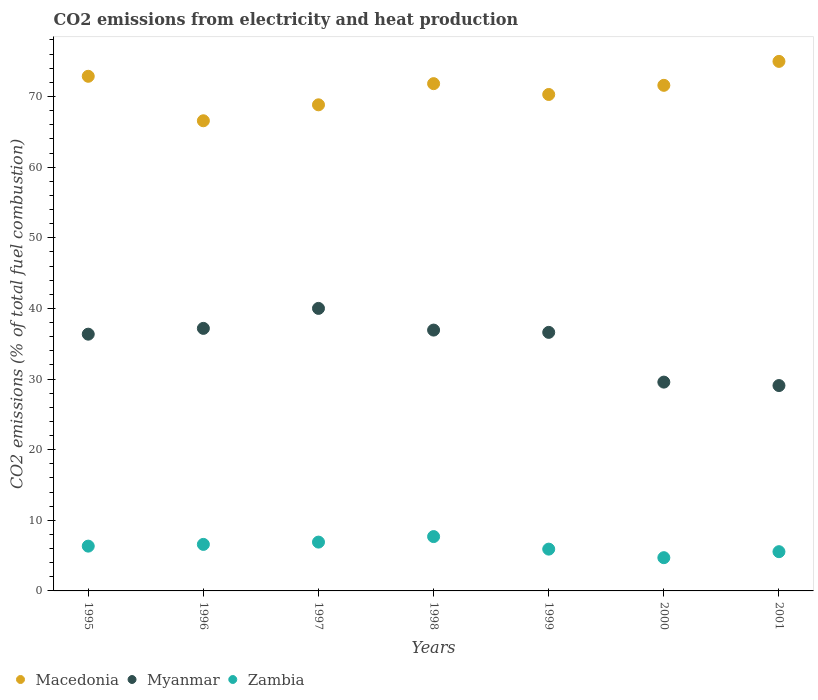How many different coloured dotlines are there?
Your response must be concise. 3. What is the amount of CO2 emitted in Myanmar in 1999?
Provide a succinct answer. 36.61. Across all years, what is the maximum amount of CO2 emitted in Myanmar?
Provide a succinct answer. 40. Across all years, what is the minimum amount of CO2 emitted in Myanmar?
Offer a very short reply. 29.08. What is the total amount of CO2 emitted in Zambia in the graph?
Offer a terse response. 43.71. What is the difference between the amount of CO2 emitted in Macedonia in 1997 and that in 2000?
Provide a succinct answer. -2.76. What is the difference between the amount of CO2 emitted in Zambia in 1999 and the amount of CO2 emitted in Macedonia in 2001?
Offer a terse response. -69.05. What is the average amount of CO2 emitted in Myanmar per year?
Provide a short and direct response. 35.1. In the year 1997, what is the difference between the amount of CO2 emitted in Macedonia and amount of CO2 emitted in Myanmar?
Your answer should be compact. 28.82. What is the ratio of the amount of CO2 emitted in Myanmar in 1996 to that in 2001?
Ensure brevity in your answer.  1.28. Is the amount of CO2 emitted in Zambia in 1997 less than that in 1998?
Provide a succinct answer. Yes. What is the difference between the highest and the second highest amount of CO2 emitted in Macedonia?
Provide a short and direct response. 2.11. What is the difference between the highest and the lowest amount of CO2 emitted in Zambia?
Your answer should be compact. 2.99. In how many years, is the amount of CO2 emitted in Macedonia greater than the average amount of CO2 emitted in Macedonia taken over all years?
Offer a very short reply. 4. Is it the case that in every year, the sum of the amount of CO2 emitted in Zambia and amount of CO2 emitted in Macedonia  is greater than the amount of CO2 emitted in Myanmar?
Your answer should be compact. Yes. Does the amount of CO2 emitted in Zambia monotonically increase over the years?
Provide a succinct answer. No. How many dotlines are there?
Provide a succinct answer. 3. How many years are there in the graph?
Provide a succinct answer. 7. Are the values on the major ticks of Y-axis written in scientific E-notation?
Provide a succinct answer. No. Does the graph contain any zero values?
Give a very brief answer. No. Where does the legend appear in the graph?
Your response must be concise. Bottom left. How many legend labels are there?
Provide a short and direct response. 3. What is the title of the graph?
Your answer should be very brief. CO2 emissions from electricity and heat production. Does "Zimbabwe" appear as one of the legend labels in the graph?
Give a very brief answer. No. What is the label or title of the X-axis?
Your answer should be compact. Years. What is the label or title of the Y-axis?
Offer a terse response. CO2 emissions (% of total fuel combustion). What is the CO2 emissions (% of total fuel combustion) of Macedonia in 1995?
Keep it short and to the point. 72.86. What is the CO2 emissions (% of total fuel combustion) of Myanmar in 1995?
Offer a terse response. 36.35. What is the CO2 emissions (% of total fuel combustion) in Zambia in 1995?
Provide a short and direct response. 6.34. What is the CO2 emissions (% of total fuel combustion) of Macedonia in 1996?
Keep it short and to the point. 66.56. What is the CO2 emissions (% of total fuel combustion) of Myanmar in 1996?
Ensure brevity in your answer.  37.17. What is the CO2 emissions (% of total fuel combustion) of Zambia in 1996?
Offer a terse response. 6.59. What is the CO2 emissions (% of total fuel combustion) of Macedonia in 1997?
Offer a terse response. 68.82. What is the CO2 emissions (% of total fuel combustion) in Myanmar in 1997?
Provide a short and direct response. 40. What is the CO2 emissions (% of total fuel combustion) of Zambia in 1997?
Make the answer very short. 6.91. What is the CO2 emissions (% of total fuel combustion) of Macedonia in 1998?
Offer a terse response. 71.82. What is the CO2 emissions (% of total fuel combustion) in Myanmar in 1998?
Ensure brevity in your answer.  36.93. What is the CO2 emissions (% of total fuel combustion) of Zambia in 1998?
Keep it short and to the point. 7.69. What is the CO2 emissions (% of total fuel combustion) in Macedonia in 1999?
Your answer should be very brief. 70.29. What is the CO2 emissions (% of total fuel combustion) in Myanmar in 1999?
Give a very brief answer. 36.61. What is the CO2 emissions (% of total fuel combustion) in Zambia in 1999?
Provide a short and direct response. 5.92. What is the CO2 emissions (% of total fuel combustion) in Macedonia in 2000?
Give a very brief answer. 71.58. What is the CO2 emissions (% of total fuel combustion) of Myanmar in 2000?
Provide a short and direct response. 29.56. What is the CO2 emissions (% of total fuel combustion) of Zambia in 2000?
Provide a succinct answer. 4.71. What is the CO2 emissions (% of total fuel combustion) of Macedonia in 2001?
Ensure brevity in your answer.  74.97. What is the CO2 emissions (% of total fuel combustion) in Myanmar in 2001?
Your answer should be very brief. 29.08. What is the CO2 emissions (% of total fuel combustion) of Zambia in 2001?
Your answer should be very brief. 5.56. Across all years, what is the maximum CO2 emissions (% of total fuel combustion) of Macedonia?
Make the answer very short. 74.97. Across all years, what is the maximum CO2 emissions (% of total fuel combustion) in Zambia?
Give a very brief answer. 7.69. Across all years, what is the minimum CO2 emissions (% of total fuel combustion) in Macedonia?
Make the answer very short. 66.56. Across all years, what is the minimum CO2 emissions (% of total fuel combustion) in Myanmar?
Give a very brief answer. 29.08. Across all years, what is the minimum CO2 emissions (% of total fuel combustion) in Zambia?
Give a very brief answer. 4.71. What is the total CO2 emissions (% of total fuel combustion) of Macedonia in the graph?
Your answer should be very brief. 496.9. What is the total CO2 emissions (% of total fuel combustion) of Myanmar in the graph?
Offer a very short reply. 245.69. What is the total CO2 emissions (% of total fuel combustion) in Zambia in the graph?
Your answer should be compact. 43.71. What is the difference between the CO2 emissions (% of total fuel combustion) in Macedonia in 1995 and that in 1996?
Provide a short and direct response. 6.3. What is the difference between the CO2 emissions (% of total fuel combustion) in Myanmar in 1995 and that in 1996?
Offer a very short reply. -0.82. What is the difference between the CO2 emissions (% of total fuel combustion) in Zambia in 1995 and that in 1996?
Offer a terse response. -0.25. What is the difference between the CO2 emissions (% of total fuel combustion) of Macedonia in 1995 and that in 1997?
Your answer should be compact. 4.04. What is the difference between the CO2 emissions (% of total fuel combustion) of Myanmar in 1995 and that in 1997?
Offer a terse response. -3.65. What is the difference between the CO2 emissions (% of total fuel combustion) of Zambia in 1995 and that in 1997?
Provide a succinct answer. -0.57. What is the difference between the CO2 emissions (% of total fuel combustion) of Macedonia in 1995 and that in 1998?
Offer a very short reply. 1.04. What is the difference between the CO2 emissions (% of total fuel combustion) in Myanmar in 1995 and that in 1998?
Offer a very short reply. -0.58. What is the difference between the CO2 emissions (% of total fuel combustion) in Zambia in 1995 and that in 1998?
Offer a very short reply. -1.35. What is the difference between the CO2 emissions (% of total fuel combustion) in Macedonia in 1995 and that in 1999?
Provide a short and direct response. 2.57. What is the difference between the CO2 emissions (% of total fuel combustion) of Myanmar in 1995 and that in 1999?
Ensure brevity in your answer.  -0.25. What is the difference between the CO2 emissions (% of total fuel combustion) of Zambia in 1995 and that in 1999?
Provide a short and direct response. 0.42. What is the difference between the CO2 emissions (% of total fuel combustion) of Macedonia in 1995 and that in 2000?
Give a very brief answer. 1.28. What is the difference between the CO2 emissions (% of total fuel combustion) of Myanmar in 1995 and that in 2000?
Your response must be concise. 6.79. What is the difference between the CO2 emissions (% of total fuel combustion) in Zambia in 1995 and that in 2000?
Your response must be concise. 1.64. What is the difference between the CO2 emissions (% of total fuel combustion) of Macedonia in 1995 and that in 2001?
Your response must be concise. -2.11. What is the difference between the CO2 emissions (% of total fuel combustion) of Myanmar in 1995 and that in 2001?
Provide a short and direct response. 7.27. What is the difference between the CO2 emissions (% of total fuel combustion) of Zambia in 1995 and that in 2001?
Offer a very short reply. 0.79. What is the difference between the CO2 emissions (% of total fuel combustion) of Macedonia in 1996 and that in 1997?
Give a very brief answer. -2.26. What is the difference between the CO2 emissions (% of total fuel combustion) in Myanmar in 1996 and that in 1997?
Make the answer very short. -2.83. What is the difference between the CO2 emissions (% of total fuel combustion) of Zambia in 1996 and that in 1997?
Your answer should be compact. -0.33. What is the difference between the CO2 emissions (% of total fuel combustion) in Macedonia in 1996 and that in 1998?
Make the answer very short. -5.26. What is the difference between the CO2 emissions (% of total fuel combustion) of Myanmar in 1996 and that in 1998?
Your response must be concise. 0.24. What is the difference between the CO2 emissions (% of total fuel combustion) in Zambia in 1996 and that in 1998?
Your answer should be compact. -1.11. What is the difference between the CO2 emissions (% of total fuel combustion) of Macedonia in 1996 and that in 1999?
Give a very brief answer. -3.72. What is the difference between the CO2 emissions (% of total fuel combustion) of Myanmar in 1996 and that in 1999?
Ensure brevity in your answer.  0.57. What is the difference between the CO2 emissions (% of total fuel combustion) of Zambia in 1996 and that in 1999?
Make the answer very short. 0.67. What is the difference between the CO2 emissions (% of total fuel combustion) of Macedonia in 1996 and that in 2000?
Ensure brevity in your answer.  -5.02. What is the difference between the CO2 emissions (% of total fuel combustion) in Myanmar in 1996 and that in 2000?
Your response must be concise. 7.61. What is the difference between the CO2 emissions (% of total fuel combustion) in Zambia in 1996 and that in 2000?
Ensure brevity in your answer.  1.88. What is the difference between the CO2 emissions (% of total fuel combustion) of Macedonia in 1996 and that in 2001?
Ensure brevity in your answer.  -8.41. What is the difference between the CO2 emissions (% of total fuel combustion) in Myanmar in 1996 and that in 2001?
Offer a terse response. 8.1. What is the difference between the CO2 emissions (% of total fuel combustion) in Zambia in 1996 and that in 2001?
Offer a very short reply. 1.03. What is the difference between the CO2 emissions (% of total fuel combustion) of Macedonia in 1997 and that in 1998?
Offer a very short reply. -3. What is the difference between the CO2 emissions (% of total fuel combustion) in Myanmar in 1997 and that in 1998?
Ensure brevity in your answer.  3.07. What is the difference between the CO2 emissions (% of total fuel combustion) of Zambia in 1997 and that in 1998?
Ensure brevity in your answer.  -0.78. What is the difference between the CO2 emissions (% of total fuel combustion) of Macedonia in 1997 and that in 1999?
Your answer should be very brief. -1.46. What is the difference between the CO2 emissions (% of total fuel combustion) of Myanmar in 1997 and that in 1999?
Offer a terse response. 3.39. What is the difference between the CO2 emissions (% of total fuel combustion) of Macedonia in 1997 and that in 2000?
Your answer should be very brief. -2.76. What is the difference between the CO2 emissions (% of total fuel combustion) in Myanmar in 1997 and that in 2000?
Give a very brief answer. 10.44. What is the difference between the CO2 emissions (% of total fuel combustion) of Zambia in 1997 and that in 2000?
Your response must be concise. 2.21. What is the difference between the CO2 emissions (% of total fuel combustion) of Macedonia in 1997 and that in 2001?
Your response must be concise. -6.15. What is the difference between the CO2 emissions (% of total fuel combustion) of Myanmar in 1997 and that in 2001?
Your response must be concise. 10.92. What is the difference between the CO2 emissions (% of total fuel combustion) in Zambia in 1997 and that in 2001?
Your answer should be very brief. 1.36. What is the difference between the CO2 emissions (% of total fuel combustion) in Macedonia in 1998 and that in 1999?
Make the answer very short. 1.53. What is the difference between the CO2 emissions (% of total fuel combustion) in Myanmar in 1998 and that in 1999?
Make the answer very short. 0.32. What is the difference between the CO2 emissions (% of total fuel combustion) in Zambia in 1998 and that in 1999?
Offer a very short reply. 1.78. What is the difference between the CO2 emissions (% of total fuel combustion) in Macedonia in 1998 and that in 2000?
Keep it short and to the point. 0.24. What is the difference between the CO2 emissions (% of total fuel combustion) of Myanmar in 1998 and that in 2000?
Offer a terse response. 7.37. What is the difference between the CO2 emissions (% of total fuel combustion) in Zambia in 1998 and that in 2000?
Offer a very short reply. 2.99. What is the difference between the CO2 emissions (% of total fuel combustion) in Macedonia in 1998 and that in 2001?
Your answer should be very brief. -3.15. What is the difference between the CO2 emissions (% of total fuel combustion) in Myanmar in 1998 and that in 2001?
Provide a succinct answer. 7.85. What is the difference between the CO2 emissions (% of total fuel combustion) in Zambia in 1998 and that in 2001?
Provide a succinct answer. 2.14. What is the difference between the CO2 emissions (% of total fuel combustion) in Macedonia in 1999 and that in 2000?
Offer a very short reply. -1.3. What is the difference between the CO2 emissions (% of total fuel combustion) of Myanmar in 1999 and that in 2000?
Offer a terse response. 7.04. What is the difference between the CO2 emissions (% of total fuel combustion) in Zambia in 1999 and that in 2000?
Provide a short and direct response. 1.21. What is the difference between the CO2 emissions (% of total fuel combustion) in Macedonia in 1999 and that in 2001?
Provide a short and direct response. -4.68. What is the difference between the CO2 emissions (% of total fuel combustion) of Myanmar in 1999 and that in 2001?
Your answer should be very brief. 7.53. What is the difference between the CO2 emissions (% of total fuel combustion) in Zambia in 1999 and that in 2001?
Offer a very short reply. 0.36. What is the difference between the CO2 emissions (% of total fuel combustion) in Macedonia in 2000 and that in 2001?
Provide a succinct answer. -3.39. What is the difference between the CO2 emissions (% of total fuel combustion) in Myanmar in 2000 and that in 2001?
Ensure brevity in your answer.  0.49. What is the difference between the CO2 emissions (% of total fuel combustion) in Zambia in 2000 and that in 2001?
Your response must be concise. -0.85. What is the difference between the CO2 emissions (% of total fuel combustion) of Macedonia in 1995 and the CO2 emissions (% of total fuel combustion) of Myanmar in 1996?
Your answer should be very brief. 35.69. What is the difference between the CO2 emissions (% of total fuel combustion) in Macedonia in 1995 and the CO2 emissions (% of total fuel combustion) in Zambia in 1996?
Make the answer very short. 66.27. What is the difference between the CO2 emissions (% of total fuel combustion) in Myanmar in 1995 and the CO2 emissions (% of total fuel combustion) in Zambia in 1996?
Give a very brief answer. 29.76. What is the difference between the CO2 emissions (% of total fuel combustion) in Macedonia in 1995 and the CO2 emissions (% of total fuel combustion) in Myanmar in 1997?
Offer a terse response. 32.86. What is the difference between the CO2 emissions (% of total fuel combustion) of Macedonia in 1995 and the CO2 emissions (% of total fuel combustion) of Zambia in 1997?
Your answer should be very brief. 65.95. What is the difference between the CO2 emissions (% of total fuel combustion) of Myanmar in 1995 and the CO2 emissions (% of total fuel combustion) of Zambia in 1997?
Your answer should be compact. 29.44. What is the difference between the CO2 emissions (% of total fuel combustion) in Macedonia in 1995 and the CO2 emissions (% of total fuel combustion) in Myanmar in 1998?
Provide a short and direct response. 35.93. What is the difference between the CO2 emissions (% of total fuel combustion) of Macedonia in 1995 and the CO2 emissions (% of total fuel combustion) of Zambia in 1998?
Keep it short and to the point. 65.17. What is the difference between the CO2 emissions (% of total fuel combustion) in Myanmar in 1995 and the CO2 emissions (% of total fuel combustion) in Zambia in 1998?
Your response must be concise. 28.66. What is the difference between the CO2 emissions (% of total fuel combustion) of Macedonia in 1995 and the CO2 emissions (% of total fuel combustion) of Myanmar in 1999?
Your answer should be very brief. 36.26. What is the difference between the CO2 emissions (% of total fuel combustion) in Macedonia in 1995 and the CO2 emissions (% of total fuel combustion) in Zambia in 1999?
Offer a terse response. 66.94. What is the difference between the CO2 emissions (% of total fuel combustion) of Myanmar in 1995 and the CO2 emissions (% of total fuel combustion) of Zambia in 1999?
Your response must be concise. 30.43. What is the difference between the CO2 emissions (% of total fuel combustion) of Macedonia in 1995 and the CO2 emissions (% of total fuel combustion) of Myanmar in 2000?
Your answer should be compact. 43.3. What is the difference between the CO2 emissions (% of total fuel combustion) in Macedonia in 1995 and the CO2 emissions (% of total fuel combustion) in Zambia in 2000?
Ensure brevity in your answer.  68.15. What is the difference between the CO2 emissions (% of total fuel combustion) in Myanmar in 1995 and the CO2 emissions (% of total fuel combustion) in Zambia in 2000?
Offer a very short reply. 31.64. What is the difference between the CO2 emissions (% of total fuel combustion) in Macedonia in 1995 and the CO2 emissions (% of total fuel combustion) in Myanmar in 2001?
Your answer should be compact. 43.79. What is the difference between the CO2 emissions (% of total fuel combustion) of Macedonia in 1995 and the CO2 emissions (% of total fuel combustion) of Zambia in 2001?
Your answer should be very brief. 67.31. What is the difference between the CO2 emissions (% of total fuel combustion) in Myanmar in 1995 and the CO2 emissions (% of total fuel combustion) in Zambia in 2001?
Your answer should be very brief. 30.79. What is the difference between the CO2 emissions (% of total fuel combustion) in Macedonia in 1996 and the CO2 emissions (% of total fuel combustion) in Myanmar in 1997?
Give a very brief answer. 26.56. What is the difference between the CO2 emissions (% of total fuel combustion) of Macedonia in 1996 and the CO2 emissions (% of total fuel combustion) of Zambia in 1997?
Your response must be concise. 59.65. What is the difference between the CO2 emissions (% of total fuel combustion) in Myanmar in 1996 and the CO2 emissions (% of total fuel combustion) in Zambia in 1997?
Make the answer very short. 30.26. What is the difference between the CO2 emissions (% of total fuel combustion) of Macedonia in 1996 and the CO2 emissions (% of total fuel combustion) of Myanmar in 1998?
Ensure brevity in your answer.  29.63. What is the difference between the CO2 emissions (% of total fuel combustion) of Macedonia in 1996 and the CO2 emissions (% of total fuel combustion) of Zambia in 1998?
Provide a succinct answer. 58.87. What is the difference between the CO2 emissions (% of total fuel combustion) in Myanmar in 1996 and the CO2 emissions (% of total fuel combustion) in Zambia in 1998?
Provide a succinct answer. 29.48. What is the difference between the CO2 emissions (% of total fuel combustion) of Macedonia in 1996 and the CO2 emissions (% of total fuel combustion) of Myanmar in 1999?
Keep it short and to the point. 29.96. What is the difference between the CO2 emissions (% of total fuel combustion) of Macedonia in 1996 and the CO2 emissions (% of total fuel combustion) of Zambia in 1999?
Give a very brief answer. 60.65. What is the difference between the CO2 emissions (% of total fuel combustion) in Myanmar in 1996 and the CO2 emissions (% of total fuel combustion) in Zambia in 1999?
Give a very brief answer. 31.25. What is the difference between the CO2 emissions (% of total fuel combustion) of Macedonia in 1996 and the CO2 emissions (% of total fuel combustion) of Myanmar in 2000?
Make the answer very short. 37. What is the difference between the CO2 emissions (% of total fuel combustion) in Macedonia in 1996 and the CO2 emissions (% of total fuel combustion) in Zambia in 2000?
Ensure brevity in your answer.  61.86. What is the difference between the CO2 emissions (% of total fuel combustion) in Myanmar in 1996 and the CO2 emissions (% of total fuel combustion) in Zambia in 2000?
Keep it short and to the point. 32.46. What is the difference between the CO2 emissions (% of total fuel combustion) in Macedonia in 1996 and the CO2 emissions (% of total fuel combustion) in Myanmar in 2001?
Provide a short and direct response. 37.49. What is the difference between the CO2 emissions (% of total fuel combustion) in Macedonia in 1996 and the CO2 emissions (% of total fuel combustion) in Zambia in 2001?
Offer a very short reply. 61.01. What is the difference between the CO2 emissions (% of total fuel combustion) of Myanmar in 1996 and the CO2 emissions (% of total fuel combustion) of Zambia in 2001?
Make the answer very short. 31.61. What is the difference between the CO2 emissions (% of total fuel combustion) of Macedonia in 1997 and the CO2 emissions (% of total fuel combustion) of Myanmar in 1998?
Provide a succinct answer. 31.89. What is the difference between the CO2 emissions (% of total fuel combustion) of Macedonia in 1997 and the CO2 emissions (% of total fuel combustion) of Zambia in 1998?
Provide a short and direct response. 61.13. What is the difference between the CO2 emissions (% of total fuel combustion) in Myanmar in 1997 and the CO2 emissions (% of total fuel combustion) in Zambia in 1998?
Offer a very short reply. 32.31. What is the difference between the CO2 emissions (% of total fuel combustion) of Macedonia in 1997 and the CO2 emissions (% of total fuel combustion) of Myanmar in 1999?
Ensure brevity in your answer.  32.22. What is the difference between the CO2 emissions (% of total fuel combustion) in Macedonia in 1997 and the CO2 emissions (% of total fuel combustion) in Zambia in 1999?
Your answer should be compact. 62.91. What is the difference between the CO2 emissions (% of total fuel combustion) in Myanmar in 1997 and the CO2 emissions (% of total fuel combustion) in Zambia in 1999?
Give a very brief answer. 34.08. What is the difference between the CO2 emissions (% of total fuel combustion) of Macedonia in 1997 and the CO2 emissions (% of total fuel combustion) of Myanmar in 2000?
Your answer should be compact. 39.26. What is the difference between the CO2 emissions (% of total fuel combustion) in Macedonia in 1997 and the CO2 emissions (% of total fuel combustion) in Zambia in 2000?
Make the answer very short. 64.12. What is the difference between the CO2 emissions (% of total fuel combustion) of Myanmar in 1997 and the CO2 emissions (% of total fuel combustion) of Zambia in 2000?
Give a very brief answer. 35.29. What is the difference between the CO2 emissions (% of total fuel combustion) in Macedonia in 1997 and the CO2 emissions (% of total fuel combustion) in Myanmar in 2001?
Offer a very short reply. 39.75. What is the difference between the CO2 emissions (% of total fuel combustion) in Macedonia in 1997 and the CO2 emissions (% of total fuel combustion) in Zambia in 2001?
Offer a very short reply. 63.27. What is the difference between the CO2 emissions (% of total fuel combustion) of Myanmar in 1997 and the CO2 emissions (% of total fuel combustion) of Zambia in 2001?
Give a very brief answer. 34.44. What is the difference between the CO2 emissions (% of total fuel combustion) in Macedonia in 1998 and the CO2 emissions (% of total fuel combustion) in Myanmar in 1999?
Keep it short and to the point. 35.21. What is the difference between the CO2 emissions (% of total fuel combustion) in Macedonia in 1998 and the CO2 emissions (% of total fuel combustion) in Zambia in 1999?
Offer a very short reply. 65.9. What is the difference between the CO2 emissions (% of total fuel combustion) of Myanmar in 1998 and the CO2 emissions (% of total fuel combustion) of Zambia in 1999?
Your answer should be compact. 31.01. What is the difference between the CO2 emissions (% of total fuel combustion) in Macedonia in 1998 and the CO2 emissions (% of total fuel combustion) in Myanmar in 2000?
Keep it short and to the point. 42.26. What is the difference between the CO2 emissions (% of total fuel combustion) of Macedonia in 1998 and the CO2 emissions (% of total fuel combustion) of Zambia in 2000?
Offer a terse response. 67.11. What is the difference between the CO2 emissions (% of total fuel combustion) in Myanmar in 1998 and the CO2 emissions (% of total fuel combustion) in Zambia in 2000?
Offer a very short reply. 32.22. What is the difference between the CO2 emissions (% of total fuel combustion) of Macedonia in 1998 and the CO2 emissions (% of total fuel combustion) of Myanmar in 2001?
Provide a succinct answer. 42.74. What is the difference between the CO2 emissions (% of total fuel combustion) in Macedonia in 1998 and the CO2 emissions (% of total fuel combustion) in Zambia in 2001?
Ensure brevity in your answer.  66.26. What is the difference between the CO2 emissions (% of total fuel combustion) in Myanmar in 1998 and the CO2 emissions (% of total fuel combustion) in Zambia in 2001?
Make the answer very short. 31.37. What is the difference between the CO2 emissions (% of total fuel combustion) of Macedonia in 1999 and the CO2 emissions (% of total fuel combustion) of Myanmar in 2000?
Your response must be concise. 40.72. What is the difference between the CO2 emissions (% of total fuel combustion) of Macedonia in 1999 and the CO2 emissions (% of total fuel combustion) of Zambia in 2000?
Your answer should be very brief. 65.58. What is the difference between the CO2 emissions (% of total fuel combustion) of Myanmar in 1999 and the CO2 emissions (% of total fuel combustion) of Zambia in 2000?
Your response must be concise. 31.9. What is the difference between the CO2 emissions (% of total fuel combustion) of Macedonia in 1999 and the CO2 emissions (% of total fuel combustion) of Myanmar in 2001?
Your response must be concise. 41.21. What is the difference between the CO2 emissions (% of total fuel combustion) of Macedonia in 1999 and the CO2 emissions (% of total fuel combustion) of Zambia in 2001?
Your response must be concise. 64.73. What is the difference between the CO2 emissions (% of total fuel combustion) of Myanmar in 1999 and the CO2 emissions (% of total fuel combustion) of Zambia in 2001?
Offer a terse response. 31.05. What is the difference between the CO2 emissions (% of total fuel combustion) in Macedonia in 2000 and the CO2 emissions (% of total fuel combustion) in Myanmar in 2001?
Your response must be concise. 42.51. What is the difference between the CO2 emissions (% of total fuel combustion) in Macedonia in 2000 and the CO2 emissions (% of total fuel combustion) in Zambia in 2001?
Ensure brevity in your answer.  66.03. What is the difference between the CO2 emissions (% of total fuel combustion) in Myanmar in 2000 and the CO2 emissions (% of total fuel combustion) in Zambia in 2001?
Offer a very short reply. 24.01. What is the average CO2 emissions (% of total fuel combustion) in Macedonia per year?
Give a very brief answer. 70.99. What is the average CO2 emissions (% of total fuel combustion) of Myanmar per year?
Ensure brevity in your answer.  35.1. What is the average CO2 emissions (% of total fuel combustion) in Zambia per year?
Provide a succinct answer. 6.24. In the year 1995, what is the difference between the CO2 emissions (% of total fuel combustion) in Macedonia and CO2 emissions (% of total fuel combustion) in Myanmar?
Give a very brief answer. 36.51. In the year 1995, what is the difference between the CO2 emissions (% of total fuel combustion) of Macedonia and CO2 emissions (% of total fuel combustion) of Zambia?
Make the answer very short. 66.52. In the year 1995, what is the difference between the CO2 emissions (% of total fuel combustion) in Myanmar and CO2 emissions (% of total fuel combustion) in Zambia?
Provide a succinct answer. 30.01. In the year 1996, what is the difference between the CO2 emissions (% of total fuel combustion) of Macedonia and CO2 emissions (% of total fuel combustion) of Myanmar?
Offer a terse response. 29.39. In the year 1996, what is the difference between the CO2 emissions (% of total fuel combustion) of Macedonia and CO2 emissions (% of total fuel combustion) of Zambia?
Offer a very short reply. 59.98. In the year 1996, what is the difference between the CO2 emissions (% of total fuel combustion) in Myanmar and CO2 emissions (% of total fuel combustion) in Zambia?
Give a very brief answer. 30.58. In the year 1997, what is the difference between the CO2 emissions (% of total fuel combustion) of Macedonia and CO2 emissions (% of total fuel combustion) of Myanmar?
Offer a terse response. 28.82. In the year 1997, what is the difference between the CO2 emissions (% of total fuel combustion) of Macedonia and CO2 emissions (% of total fuel combustion) of Zambia?
Your answer should be compact. 61.91. In the year 1997, what is the difference between the CO2 emissions (% of total fuel combustion) of Myanmar and CO2 emissions (% of total fuel combustion) of Zambia?
Provide a succinct answer. 33.09. In the year 1998, what is the difference between the CO2 emissions (% of total fuel combustion) in Macedonia and CO2 emissions (% of total fuel combustion) in Myanmar?
Offer a very short reply. 34.89. In the year 1998, what is the difference between the CO2 emissions (% of total fuel combustion) in Macedonia and CO2 emissions (% of total fuel combustion) in Zambia?
Ensure brevity in your answer.  64.13. In the year 1998, what is the difference between the CO2 emissions (% of total fuel combustion) of Myanmar and CO2 emissions (% of total fuel combustion) of Zambia?
Offer a terse response. 29.24. In the year 1999, what is the difference between the CO2 emissions (% of total fuel combustion) in Macedonia and CO2 emissions (% of total fuel combustion) in Myanmar?
Offer a very short reply. 33.68. In the year 1999, what is the difference between the CO2 emissions (% of total fuel combustion) of Macedonia and CO2 emissions (% of total fuel combustion) of Zambia?
Keep it short and to the point. 64.37. In the year 1999, what is the difference between the CO2 emissions (% of total fuel combustion) in Myanmar and CO2 emissions (% of total fuel combustion) in Zambia?
Provide a succinct answer. 30.69. In the year 2000, what is the difference between the CO2 emissions (% of total fuel combustion) in Macedonia and CO2 emissions (% of total fuel combustion) in Myanmar?
Offer a very short reply. 42.02. In the year 2000, what is the difference between the CO2 emissions (% of total fuel combustion) in Macedonia and CO2 emissions (% of total fuel combustion) in Zambia?
Keep it short and to the point. 66.88. In the year 2000, what is the difference between the CO2 emissions (% of total fuel combustion) of Myanmar and CO2 emissions (% of total fuel combustion) of Zambia?
Provide a succinct answer. 24.86. In the year 2001, what is the difference between the CO2 emissions (% of total fuel combustion) in Macedonia and CO2 emissions (% of total fuel combustion) in Myanmar?
Offer a terse response. 45.9. In the year 2001, what is the difference between the CO2 emissions (% of total fuel combustion) of Macedonia and CO2 emissions (% of total fuel combustion) of Zambia?
Provide a succinct answer. 69.42. In the year 2001, what is the difference between the CO2 emissions (% of total fuel combustion) in Myanmar and CO2 emissions (% of total fuel combustion) in Zambia?
Make the answer very short. 23.52. What is the ratio of the CO2 emissions (% of total fuel combustion) in Macedonia in 1995 to that in 1996?
Provide a succinct answer. 1.09. What is the ratio of the CO2 emissions (% of total fuel combustion) of Myanmar in 1995 to that in 1996?
Your answer should be compact. 0.98. What is the ratio of the CO2 emissions (% of total fuel combustion) in Zambia in 1995 to that in 1996?
Provide a succinct answer. 0.96. What is the ratio of the CO2 emissions (% of total fuel combustion) of Macedonia in 1995 to that in 1997?
Keep it short and to the point. 1.06. What is the ratio of the CO2 emissions (% of total fuel combustion) in Myanmar in 1995 to that in 1997?
Your response must be concise. 0.91. What is the ratio of the CO2 emissions (% of total fuel combustion) of Zambia in 1995 to that in 1997?
Your answer should be compact. 0.92. What is the ratio of the CO2 emissions (% of total fuel combustion) in Macedonia in 1995 to that in 1998?
Your answer should be compact. 1.01. What is the ratio of the CO2 emissions (% of total fuel combustion) in Myanmar in 1995 to that in 1998?
Offer a terse response. 0.98. What is the ratio of the CO2 emissions (% of total fuel combustion) in Zambia in 1995 to that in 1998?
Keep it short and to the point. 0.82. What is the ratio of the CO2 emissions (% of total fuel combustion) of Macedonia in 1995 to that in 1999?
Make the answer very short. 1.04. What is the ratio of the CO2 emissions (% of total fuel combustion) in Zambia in 1995 to that in 1999?
Your response must be concise. 1.07. What is the ratio of the CO2 emissions (% of total fuel combustion) in Macedonia in 1995 to that in 2000?
Give a very brief answer. 1.02. What is the ratio of the CO2 emissions (% of total fuel combustion) in Myanmar in 1995 to that in 2000?
Offer a very short reply. 1.23. What is the ratio of the CO2 emissions (% of total fuel combustion) of Zambia in 1995 to that in 2000?
Your response must be concise. 1.35. What is the ratio of the CO2 emissions (% of total fuel combustion) in Macedonia in 1995 to that in 2001?
Offer a very short reply. 0.97. What is the ratio of the CO2 emissions (% of total fuel combustion) of Myanmar in 1995 to that in 2001?
Provide a short and direct response. 1.25. What is the ratio of the CO2 emissions (% of total fuel combustion) of Zambia in 1995 to that in 2001?
Your answer should be compact. 1.14. What is the ratio of the CO2 emissions (% of total fuel combustion) in Macedonia in 1996 to that in 1997?
Provide a short and direct response. 0.97. What is the ratio of the CO2 emissions (% of total fuel combustion) of Myanmar in 1996 to that in 1997?
Offer a very short reply. 0.93. What is the ratio of the CO2 emissions (% of total fuel combustion) of Zambia in 1996 to that in 1997?
Your answer should be compact. 0.95. What is the ratio of the CO2 emissions (% of total fuel combustion) in Macedonia in 1996 to that in 1998?
Give a very brief answer. 0.93. What is the ratio of the CO2 emissions (% of total fuel combustion) of Myanmar in 1996 to that in 1998?
Keep it short and to the point. 1.01. What is the ratio of the CO2 emissions (% of total fuel combustion) in Zambia in 1996 to that in 1998?
Offer a terse response. 0.86. What is the ratio of the CO2 emissions (% of total fuel combustion) in Macedonia in 1996 to that in 1999?
Your answer should be compact. 0.95. What is the ratio of the CO2 emissions (% of total fuel combustion) of Myanmar in 1996 to that in 1999?
Your answer should be compact. 1.02. What is the ratio of the CO2 emissions (% of total fuel combustion) of Zambia in 1996 to that in 1999?
Provide a short and direct response. 1.11. What is the ratio of the CO2 emissions (% of total fuel combustion) in Macedonia in 1996 to that in 2000?
Your response must be concise. 0.93. What is the ratio of the CO2 emissions (% of total fuel combustion) of Myanmar in 1996 to that in 2000?
Your answer should be very brief. 1.26. What is the ratio of the CO2 emissions (% of total fuel combustion) of Zambia in 1996 to that in 2000?
Provide a short and direct response. 1.4. What is the ratio of the CO2 emissions (% of total fuel combustion) of Macedonia in 1996 to that in 2001?
Your response must be concise. 0.89. What is the ratio of the CO2 emissions (% of total fuel combustion) in Myanmar in 1996 to that in 2001?
Provide a short and direct response. 1.28. What is the ratio of the CO2 emissions (% of total fuel combustion) of Zambia in 1996 to that in 2001?
Offer a terse response. 1.19. What is the ratio of the CO2 emissions (% of total fuel combustion) in Myanmar in 1997 to that in 1998?
Offer a terse response. 1.08. What is the ratio of the CO2 emissions (% of total fuel combustion) of Zambia in 1997 to that in 1998?
Your answer should be compact. 0.9. What is the ratio of the CO2 emissions (% of total fuel combustion) of Macedonia in 1997 to that in 1999?
Your response must be concise. 0.98. What is the ratio of the CO2 emissions (% of total fuel combustion) in Myanmar in 1997 to that in 1999?
Keep it short and to the point. 1.09. What is the ratio of the CO2 emissions (% of total fuel combustion) in Zambia in 1997 to that in 1999?
Provide a succinct answer. 1.17. What is the ratio of the CO2 emissions (% of total fuel combustion) in Macedonia in 1997 to that in 2000?
Your answer should be very brief. 0.96. What is the ratio of the CO2 emissions (% of total fuel combustion) of Myanmar in 1997 to that in 2000?
Your answer should be compact. 1.35. What is the ratio of the CO2 emissions (% of total fuel combustion) in Zambia in 1997 to that in 2000?
Provide a succinct answer. 1.47. What is the ratio of the CO2 emissions (% of total fuel combustion) in Macedonia in 1997 to that in 2001?
Your answer should be very brief. 0.92. What is the ratio of the CO2 emissions (% of total fuel combustion) of Myanmar in 1997 to that in 2001?
Ensure brevity in your answer.  1.38. What is the ratio of the CO2 emissions (% of total fuel combustion) in Zambia in 1997 to that in 2001?
Give a very brief answer. 1.24. What is the ratio of the CO2 emissions (% of total fuel combustion) in Macedonia in 1998 to that in 1999?
Ensure brevity in your answer.  1.02. What is the ratio of the CO2 emissions (% of total fuel combustion) of Myanmar in 1998 to that in 1999?
Provide a succinct answer. 1.01. What is the ratio of the CO2 emissions (% of total fuel combustion) of Zambia in 1998 to that in 1999?
Your answer should be very brief. 1.3. What is the ratio of the CO2 emissions (% of total fuel combustion) in Myanmar in 1998 to that in 2000?
Your response must be concise. 1.25. What is the ratio of the CO2 emissions (% of total fuel combustion) in Zambia in 1998 to that in 2000?
Your answer should be very brief. 1.63. What is the ratio of the CO2 emissions (% of total fuel combustion) in Macedonia in 1998 to that in 2001?
Provide a succinct answer. 0.96. What is the ratio of the CO2 emissions (% of total fuel combustion) in Myanmar in 1998 to that in 2001?
Your answer should be compact. 1.27. What is the ratio of the CO2 emissions (% of total fuel combustion) of Zambia in 1998 to that in 2001?
Offer a terse response. 1.38. What is the ratio of the CO2 emissions (% of total fuel combustion) of Macedonia in 1999 to that in 2000?
Provide a short and direct response. 0.98. What is the ratio of the CO2 emissions (% of total fuel combustion) in Myanmar in 1999 to that in 2000?
Your response must be concise. 1.24. What is the ratio of the CO2 emissions (% of total fuel combustion) in Zambia in 1999 to that in 2000?
Offer a very short reply. 1.26. What is the ratio of the CO2 emissions (% of total fuel combustion) in Macedonia in 1999 to that in 2001?
Provide a succinct answer. 0.94. What is the ratio of the CO2 emissions (% of total fuel combustion) in Myanmar in 1999 to that in 2001?
Keep it short and to the point. 1.26. What is the ratio of the CO2 emissions (% of total fuel combustion) of Zambia in 1999 to that in 2001?
Give a very brief answer. 1.07. What is the ratio of the CO2 emissions (% of total fuel combustion) in Macedonia in 2000 to that in 2001?
Your answer should be very brief. 0.95. What is the ratio of the CO2 emissions (% of total fuel combustion) of Myanmar in 2000 to that in 2001?
Provide a succinct answer. 1.02. What is the ratio of the CO2 emissions (% of total fuel combustion) in Zambia in 2000 to that in 2001?
Provide a succinct answer. 0.85. What is the difference between the highest and the second highest CO2 emissions (% of total fuel combustion) in Macedonia?
Ensure brevity in your answer.  2.11. What is the difference between the highest and the second highest CO2 emissions (% of total fuel combustion) in Myanmar?
Your response must be concise. 2.83. What is the difference between the highest and the second highest CO2 emissions (% of total fuel combustion) of Zambia?
Make the answer very short. 0.78. What is the difference between the highest and the lowest CO2 emissions (% of total fuel combustion) in Macedonia?
Provide a succinct answer. 8.41. What is the difference between the highest and the lowest CO2 emissions (% of total fuel combustion) of Myanmar?
Your answer should be very brief. 10.92. What is the difference between the highest and the lowest CO2 emissions (% of total fuel combustion) in Zambia?
Provide a short and direct response. 2.99. 